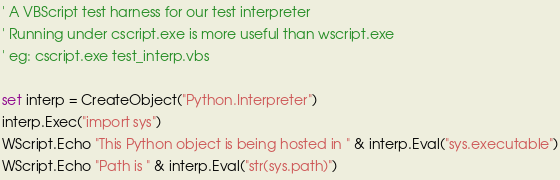<code> <loc_0><loc_0><loc_500><loc_500><_VisualBasic_>' A VBScript test harness for our test interpreter
' Running under cscript.exe is more useful than wscript.exe
' eg: cscript.exe test_interp.vbs

set interp = CreateObject("Python.Interpreter")
interp.Exec("import sys")
WScript.Echo "This Python object is being hosted in " & interp.Eval("sys.executable")
WScript.Echo "Path is " & interp.Eval("str(sys.path)")</code> 